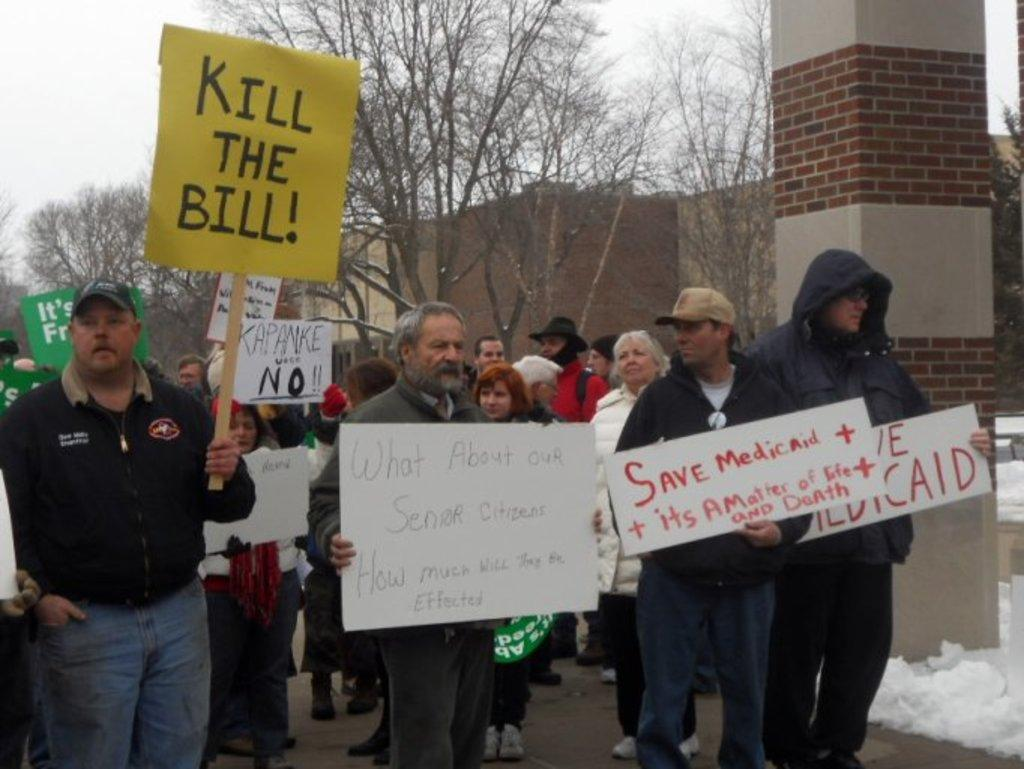What are the people on the road doing in the image? The people on the road are holding placards in the image. What type of vegetation can be seen in the image? There are trees in the image. What type of structure is visible in the image? There is a building in the image. What architectural feature can be seen in the image? There is a stone pillar in the image. What is the condition of the ground in the image? The ground has snow on it in the image. What is visible in the sky in the image? The sky is visible in the image. Where is the sister of the person holding the placard in the image? There is no mention of a sister in the image, so we cannot determine her location. What type of ring can be seen on the stone pillar in the image? There is no ring present on the stone pillar in the image. 